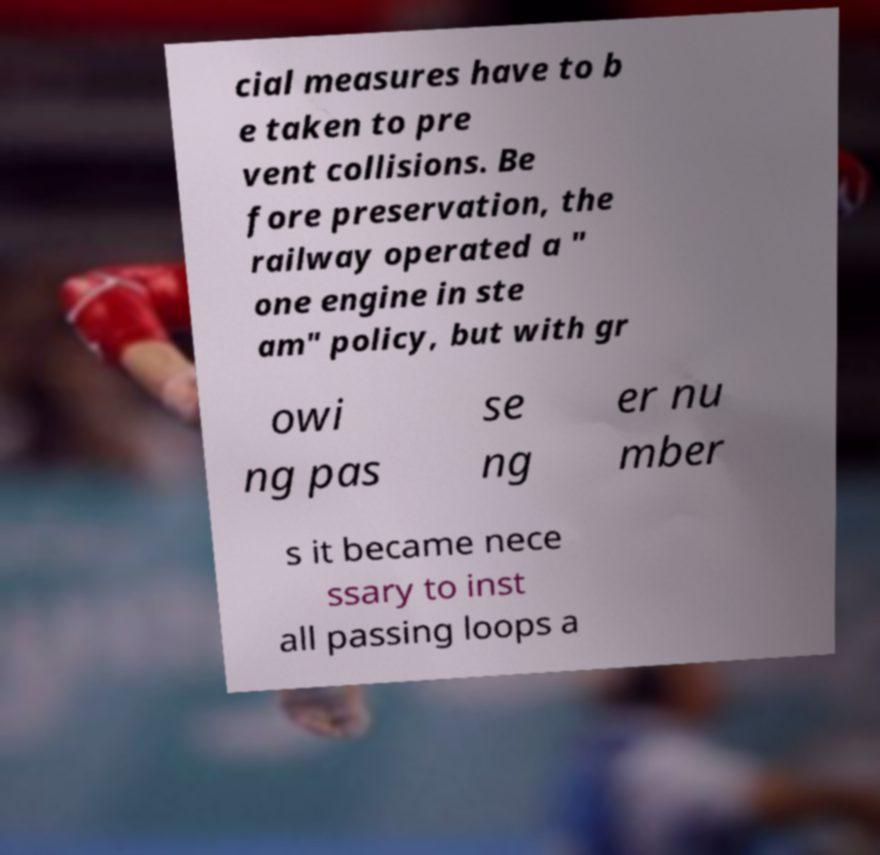Can you accurately transcribe the text from the provided image for me? cial measures have to b e taken to pre vent collisions. Be fore preservation, the railway operated a " one engine in ste am" policy, but with gr owi ng pas se ng er nu mber s it became nece ssary to inst all passing loops a 